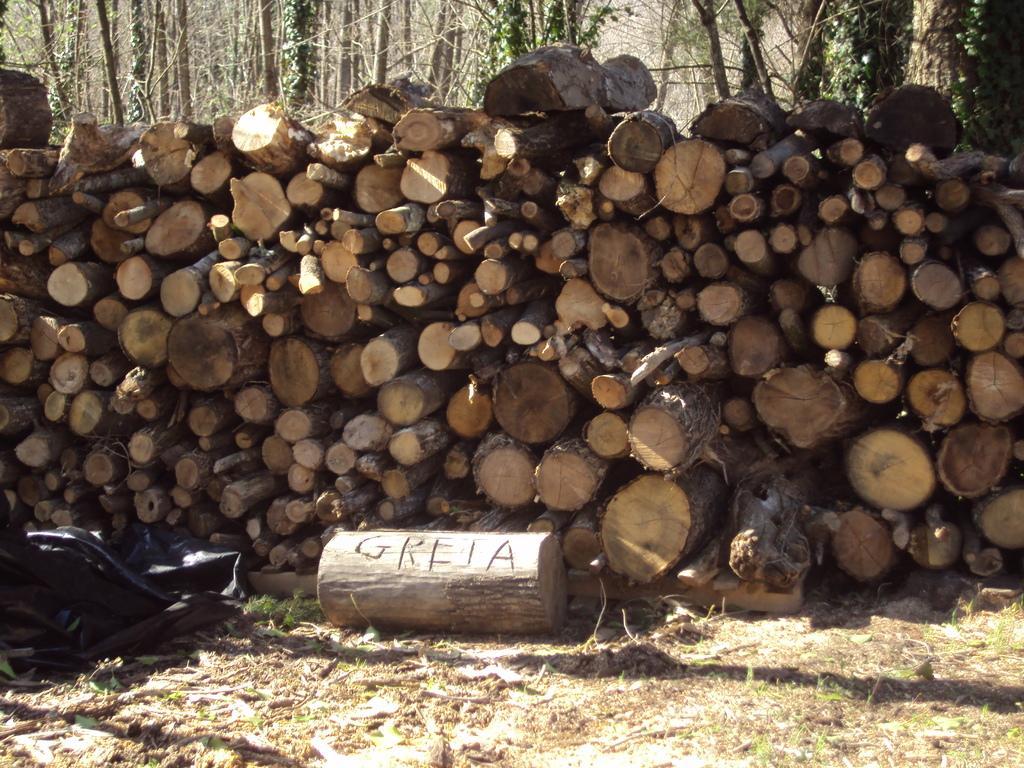In one or two sentences, can you explain what this image depicts? In this image I can see the ground, a black colored object on the ground and number of wooden logs on the ground. In the background I can see few trees. 